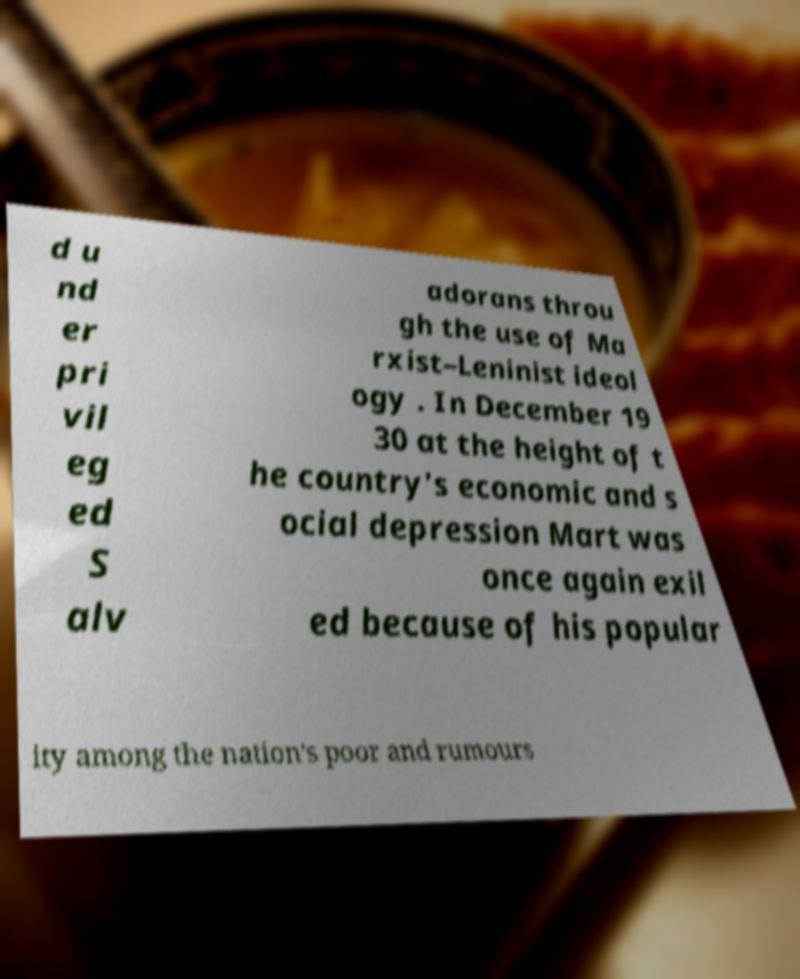Could you assist in decoding the text presented in this image and type it out clearly? d u nd er pri vil eg ed S alv adorans throu gh the use of Ma rxist–Leninist ideol ogy . In December 19 30 at the height of t he country's economic and s ocial depression Mart was once again exil ed because of his popular ity among the nation's poor and rumours 